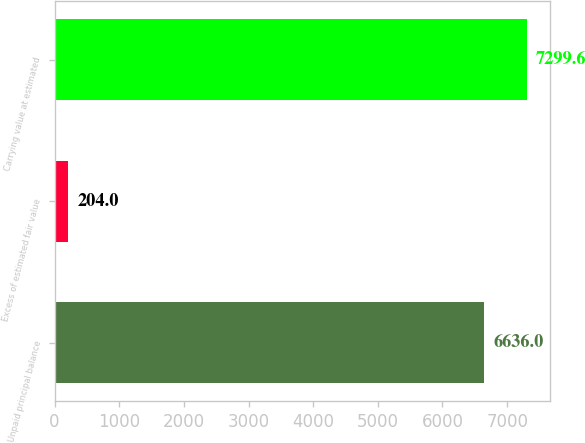<chart> <loc_0><loc_0><loc_500><loc_500><bar_chart><fcel>Unpaid principal balance<fcel>Excess of estimated fair value<fcel>Carrying value at estimated<nl><fcel>6636<fcel>204<fcel>7299.6<nl></chart> 